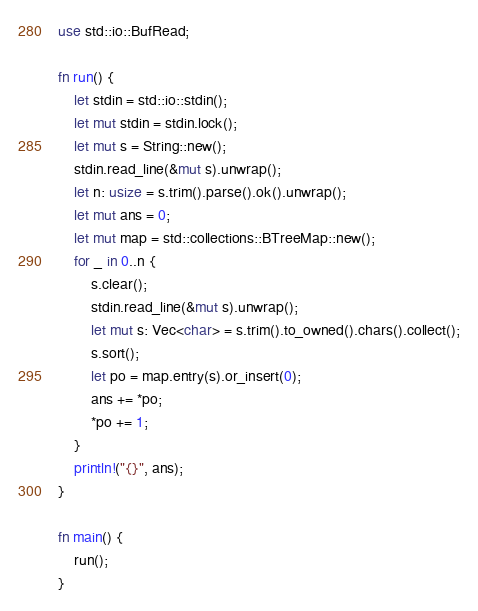<code> <loc_0><loc_0><loc_500><loc_500><_Rust_>use std::io::BufRead;

fn run() {
    let stdin = std::io::stdin();
    let mut stdin = stdin.lock();
    let mut s = String::new();
    stdin.read_line(&mut s).unwrap();
    let n: usize = s.trim().parse().ok().unwrap();
    let mut ans = 0;
    let mut map = std::collections::BTreeMap::new();
    for _ in 0..n {
        s.clear();
        stdin.read_line(&mut s).unwrap();
        let mut s: Vec<char> = s.trim().to_owned().chars().collect();
        s.sort();
        let po = map.entry(s).or_insert(0);
        ans += *po;
        *po += 1;
    }
    println!("{}", ans);
}

fn main() {
    run();
}
</code> 